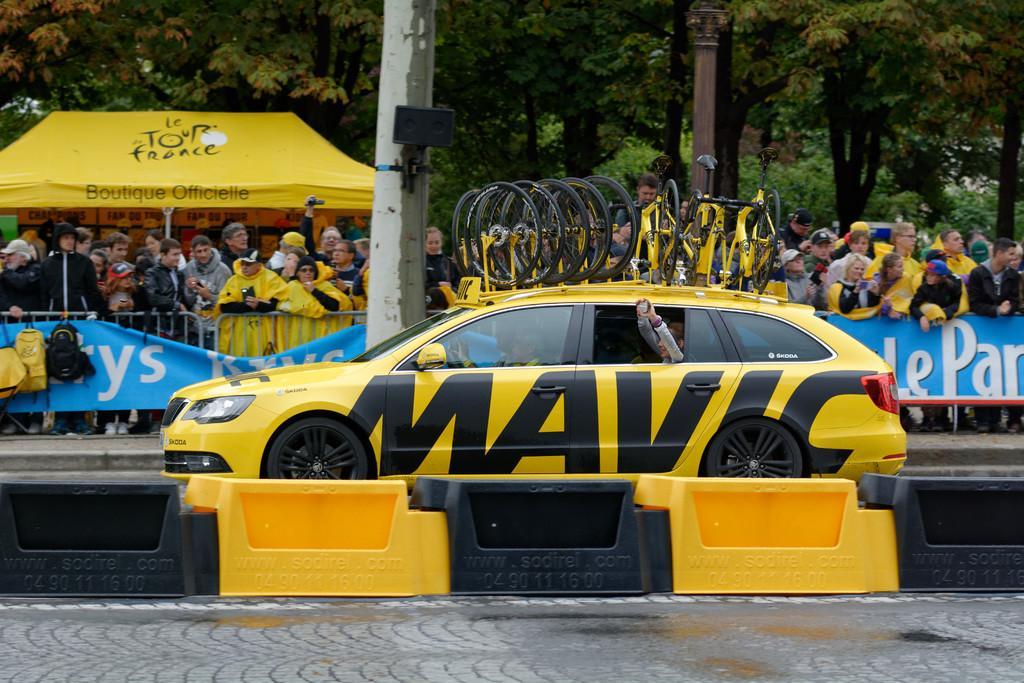Describe this image in one or two sentences. There is an event going on,a yellow car is moving on a road. Behind the car a lot of crowd is standing behind a fencing. Most of them are wearing yellow attire and some people are holding the yellow cycles and in the background there is a yellow tent,behind the tent there are a lot of trees. 